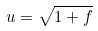<formula> <loc_0><loc_0><loc_500><loc_500>u = \sqrt { 1 + f }</formula> 